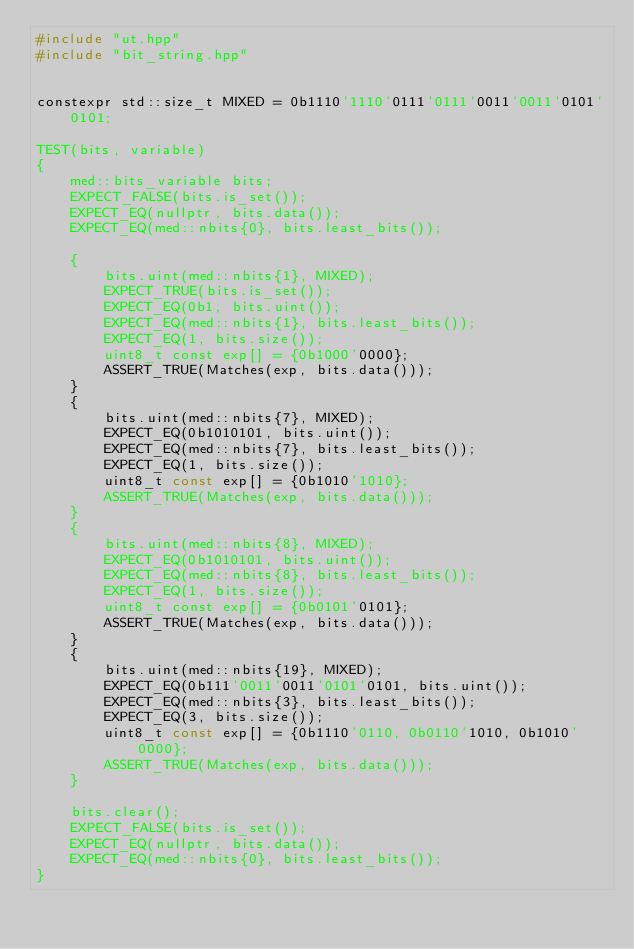Convert code to text. <code><loc_0><loc_0><loc_500><loc_500><_C++_>#include "ut.hpp"
#include "bit_string.hpp"


constexpr std::size_t MIXED = 0b1110'1110'0111'0111'0011'0011'0101'0101;

TEST(bits, variable)
{
	med::bits_variable bits;
	EXPECT_FALSE(bits.is_set());
	EXPECT_EQ(nullptr, bits.data());
	EXPECT_EQ(med::nbits{0}, bits.least_bits());

	{
		bits.uint(med::nbits{1}, MIXED);
		EXPECT_TRUE(bits.is_set());
		EXPECT_EQ(0b1, bits.uint());
		EXPECT_EQ(med::nbits{1}, bits.least_bits());
		EXPECT_EQ(1, bits.size());
		uint8_t const exp[] = {0b1000'0000};
		ASSERT_TRUE(Matches(exp, bits.data()));
	}
	{
		bits.uint(med::nbits{7}, MIXED);
		EXPECT_EQ(0b1010101, bits.uint());
		EXPECT_EQ(med::nbits{7}, bits.least_bits());
		EXPECT_EQ(1, bits.size());
		uint8_t const exp[] = {0b1010'1010};
		ASSERT_TRUE(Matches(exp, bits.data()));
	}
	{
		bits.uint(med::nbits{8}, MIXED);
		EXPECT_EQ(0b1010101, bits.uint());
		EXPECT_EQ(med::nbits{8}, bits.least_bits());
		EXPECT_EQ(1, bits.size());
		uint8_t const exp[] = {0b0101'0101};
		ASSERT_TRUE(Matches(exp, bits.data()));
	}
	{
		bits.uint(med::nbits{19}, MIXED);
		EXPECT_EQ(0b111'0011'0011'0101'0101, bits.uint());
		EXPECT_EQ(med::nbits{3}, bits.least_bits());
		EXPECT_EQ(3, bits.size());
		uint8_t const exp[] = {0b1110'0110, 0b0110'1010, 0b1010'0000};
		ASSERT_TRUE(Matches(exp, bits.data()));
	}

	bits.clear();
	EXPECT_FALSE(bits.is_set());
	EXPECT_EQ(nullptr, bits.data());
	EXPECT_EQ(med::nbits{0}, bits.least_bits());
}
</code> 